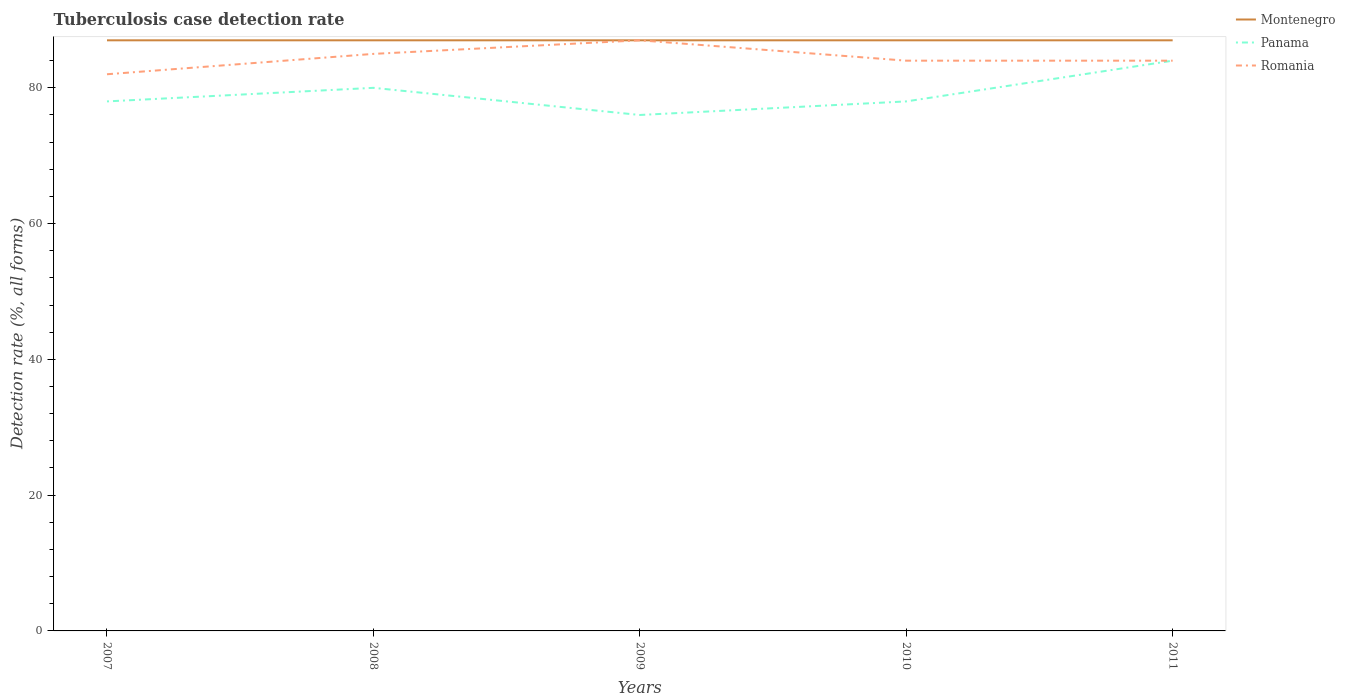How many different coloured lines are there?
Your answer should be compact. 3. Across all years, what is the maximum tuberculosis case detection rate in in Panama?
Provide a succinct answer. 76. In which year was the tuberculosis case detection rate in in Panama maximum?
Your answer should be compact. 2009. What is the total tuberculosis case detection rate in in Montenegro in the graph?
Your response must be concise. 0. What is the difference between the highest and the second highest tuberculosis case detection rate in in Panama?
Your answer should be compact. 8. What is the difference between the highest and the lowest tuberculosis case detection rate in in Panama?
Provide a succinct answer. 2. How many years are there in the graph?
Make the answer very short. 5. What is the difference between two consecutive major ticks on the Y-axis?
Give a very brief answer. 20. Are the values on the major ticks of Y-axis written in scientific E-notation?
Your response must be concise. No. Does the graph contain any zero values?
Offer a very short reply. No. How are the legend labels stacked?
Give a very brief answer. Vertical. What is the title of the graph?
Ensure brevity in your answer.  Tuberculosis case detection rate. What is the label or title of the Y-axis?
Keep it short and to the point. Detection rate (%, all forms). What is the Detection rate (%, all forms) of Romania in 2007?
Offer a terse response. 82. What is the Detection rate (%, all forms) of Romania in 2008?
Offer a very short reply. 85. What is the Detection rate (%, all forms) in Montenegro in 2009?
Offer a terse response. 87. What is the Detection rate (%, all forms) in Panama in 2009?
Offer a very short reply. 76. What is the Detection rate (%, all forms) of Montenegro in 2010?
Offer a terse response. 87. What is the Detection rate (%, all forms) in Panama in 2010?
Your answer should be very brief. 78. What is the Detection rate (%, all forms) of Romania in 2010?
Make the answer very short. 84. What is the Detection rate (%, all forms) of Panama in 2011?
Give a very brief answer. 84. Across all years, what is the maximum Detection rate (%, all forms) in Montenegro?
Provide a short and direct response. 87. Across all years, what is the maximum Detection rate (%, all forms) in Romania?
Keep it short and to the point. 87. Across all years, what is the minimum Detection rate (%, all forms) of Montenegro?
Your response must be concise. 87. What is the total Detection rate (%, all forms) in Montenegro in the graph?
Offer a terse response. 435. What is the total Detection rate (%, all forms) in Panama in the graph?
Provide a succinct answer. 396. What is the total Detection rate (%, all forms) in Romania in the graph?
Provide a succinct answer. 422. What is the difference between the Detection rate (%, all forms) in Montenegro in 2007 and that in 2008?
Provide a succinct answer. 0. What is the difference between the Detection rate (%, all forms) in Panama in 2008 and that in 2010?
Provide a succinct answer. 2. What is the difference between the Detection rate (%, all forms) of Panama in 2009 and that in 2010?
Offer a very short reply. -2. What is the difference between the Detection rate (%, all forms) of Romania in 2009 and that in 2010?
Provide a succinct answer. 3. What is the difference between the Detection rate (%, all forms) in Montenegro in 2009 and that in 2011?
Offer a terse response. 0. What is the difference between the Detection rate (%, all forms) in Panama in 2009 and that in 2011?
Your answer should be compact. -8. What is the difference between the Detection rate (%, all forms) in Panama in 2010 and that in 2011?
Your answer should be very brief. -6. What is the difference between the Detection rate (%, all forms) in Romania in 2010 and that in 2011?
Ensure brevity in your answer.  0. What is the difference between the Detection rate (%, all forms) of Montenegro in 2007 and the Detection rate (%, all forms) of Romania in 2009?
Offer a terse response. 0. What is the difference between the Detection rate (%, all forms) in Panama in 2007 and the Detection rate (%, all forms) in Romania in 2009?
Your response must be concise. -9. What is the difference between the Detection rate (%, all forms) in Montenegro in 2007 and the Detection rate (%, all forms) in Romania in 2010?
Provide a short and direct response. 3. What is the difference between the Detection rate (%, all forms) in Montenegro in 2007 and the Detection rate (%, all forms) in Romania in 2011?
Your answer should be compact. 3. What is the difference between the Detection rate (%, all forms) of Montenegro in 2008 and the Detection rate (%, all forms) of Panama in 2009?
Provide a succinct answer. 11. What is the difference between the Detection rate (%, all forms) of Montenegro in 2008 and the Detection rate (%, all forms) of Romania in 2009?
Your answer should be compact. 0. What is the difference between the Detection rate (%, all forms) in Panama in 2008 and the Detection rate (%, all forms) in Romania in 2009?
Give a very brief answer. -7. What is the difference between the Detection rate (%, all forms) in Panama in 2008 and the Detection rate (%, all forms) in Romania in 2010?
Your answer should be compact. -4. What is the difference between the Detection rate (%, all forms) of Panama in 2008 and the Detection rate (%, all forms) of Romania in 2011?
Offer a terse response. -4. What is the difference between the Detection rate (%, all forms) of Montenegro in 2009 and the Detection rate (%, all forms) of Panama in 2010?
Ensure brevity in your answer.  9. What is the difference between the Detection rate (%, all forms) in Montenegro in 2009 and the Detection rate (%, all forms) in Romania in 2010?
Offer a very short reply. 3. What is the difference between the Detection rate (%, all forms) of Montenegro in 2009 and the Detection rate (%, all forms) of Romania in 2011?
Your answer should be very brief. 3. What is the difference between the Detection rate (%, all forms) in Panama in 2009 and the Detection rate (%, all forms) in Romania in 2011?
Offer a terse response. -8. What is the difference between the Detection rate (%, all forms) in Montenegro in 2010 and the Detection rate (%, all forms) in Panama in 2011?
Keep it short and to the point. 3. What is the difference between the Detection rate (%, all forms) of Panama in 2010 and the Detection rate (%, all forms) of Romania in 2011?
Your response must be concise. -6. What is the average Detection rate (%, all forms) of Panama per year?
Keep it short and to the point. 79.2. What is the average Detection rate (%, all forms) in Romania per year?
Your answer should be very brief. 84.4. In the year 2009, what is the difference between the Detection rate (%, all forms) of Montenegro and Detection rate (%, all forms) of Romania?
Provide a short and direct response. 0. In the year 2010, what is the difference between the Detection rate (%, all forms) in Montenegro and Detection rate (%, all forms) in Panama?
Your answer should be compact. 9. In the year 2010, what is the difference between the Detection rate (%, all forms) of Panama and Detection rate (%, all forms) of Romania?
Give a very brief answer. -6. In the year 2011, what is the difference between the Detection rate (%, all forms) in Montenegro and Detection rate (%, all forms) in Romania?
Keep it short and to the point. 3. In the year 2011, what is the difference between the Detection rate (%, all forms) in Panama and Detection rate (%, all forms) in Romania?
Provide a short and direct response. 0. What is the ratio of the Detection rate (%, all forms) in Montenegro in 2007 to that in 2008?
Your answer should be very brief. 1. What is the ratio of the Detection rate (%, all forms) of Romania in 2007 to that in 2008?
Make the answer very short. 0.96. What is the ratio of the Detection rate (%, all forms) of Montenegro in 2007 to that in 2009?
Provide a succinct answer. 1. What is the ratio of the Detection rate (%, all forms) of Panama in 2007 to that in 2009?
Give a very brief answer. 1.03. What is the ratio of the Detection rate (%, all forms) of Romania in 2007 to that in 2009?
Offer a terse response. 0.94. What is the ratio of the Detection rate (%, all forms) in Panama in 2007 to that in 2010?
Offer a terse response. 1. What is the ratio of the Detection rate (%, all forms) in Romania in 2007 to that in 2010?
Your answer should be compact. 0.98. What is the ratio of the Detection rate (%, all forms) in Montenegro in 2007 to that in 2011?
Give a very brief answer. 1. What is the ratio of the Detection rate (%, all forms) of Romania in 2007 to that in 2011?
Provide a succinct answer. 0.98. What is the ratio of the Detection rate (%, all forms) in Montenegro in 2008 to that in 2009?
Make the answer very short. 1. What is the ratio of the Detection rate (%, all forms) of Panama in 2008 to that in 2009?
Your response must be concise. 1.05. What is the ratio of the Detection rate (%, all forms) of Romania in 2008 to that in 2009?
Keep it short and to the point. 0.98. What is the ratio of the Detection rate (%, all forms) of Panama in 2008 to that in 2010?
Offer a terse response. 1.03. What is the ratio of the Detection rate (%, all forms) of Romania in 2008 to that in 2010?
Your answer should be very brief. 1.01. What is the ratio of the Detection rate (%, all forms) of Panama in 2008 to that in 2011?
Provide a short and direct response. 0.95. What is the ratio of the Detection rate (%, all forms) of Romania in 2008 to that in 2011?
Provide a short and direct response. 1.01. What is the ratio of the Detection rate (%, all forms) of Montenegro in 2009 to that in 2010?
Offer a terse response. 1. What is the ratio of the Detection rate (%, all forms) of Panama in 2009 to that in 2010?
Your answer should be very brief. 0.97. What is the ratio of the Detection rate (%, all forms) in Romania in 2009 to that in 2010?
Offer a terse response. 1.04. What is the ratio of the Detection rate (%, all forms) in Montenegro in 2009 to that in 2011?
Provide a short and direct response. 1. What is the ratio of the Detection rate (%, all forms) of Panama in 2009 to that in 2011?
Provide a succinct answer. 0.9. What is the ratio of the Detection rate (%, all forms) in Romania in 2009 to that in 2011?
Your answer should be very brief. 1.04. What is the ratio of the Detection rate (%, all forms) in Montenegro in 2010 to that in 2011?
Keep it short and to the point. 1. What is the difference between the highest and the second highest Detection rate (%, all forms) in Panama?
Ensure brevity in your answer.  4. What is the difference between the highest and the second highest Detection rate (%, all forms) of Romania?
Your answer should be compact. 2. What is the difference between the highest and the lowest Detection rate (%, all forms) of Montenegro?
Keep it short and to the point. 0. What is the difference between the highest and the lowest Detection rate (%, all forms) of Romania?
Keep it short and to the point. 5. 